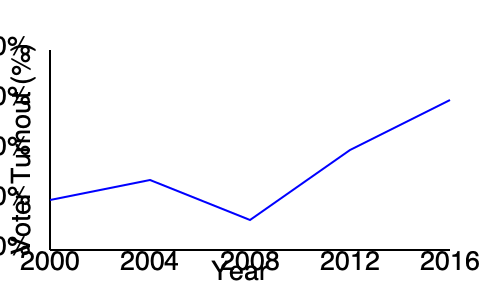Based on the voter turnout trends shown in the line graph, which election year saw the highest voter turnout, and what strategic implications might this have for an opposition party's platform? To answer this question, we need to analyze the graph and consider its implications:

1. Examine the graph: The line represents voter turnout percentages from 2000 to 2016.

2. Identify the highest point: The graph reaches its peak in 2016, indicating the highest voter turnout.

3. Consider the trend: There's an overall upward trend from 2000 to 2016, with a slight dip in 2008.

4. Strategic implications for the opposition:
   a) High turnout often indicates increased political engagement, which could be leveraged.
   b) The opposition might focus on mobilizing new voters who contributed to the high turnout.
   c) Analyze demographic shifts that may have led to increased participation.
   d) Consider issues that drove higher turnout and incorporate them into the platform.
   e) Develop strategies to maintain or further increase voter engagement.

5. Platform adjustments:
   a) Address concerns that motivated higher turnout.
   b) Focus on inclusive policies to appeal to a broader electorate.
   c) Emphasize the importance of civic participation in campaign messaging.

The highest turnout in 2016 suggests a highly engaged electorate, presenting an opportunity for the opposition to capitalize on this energy by tailoring their platform to address the issues driving increased participation.
Answer: 2016; Opportunity to engage highly motivated electorate and address driving issues in platform. 